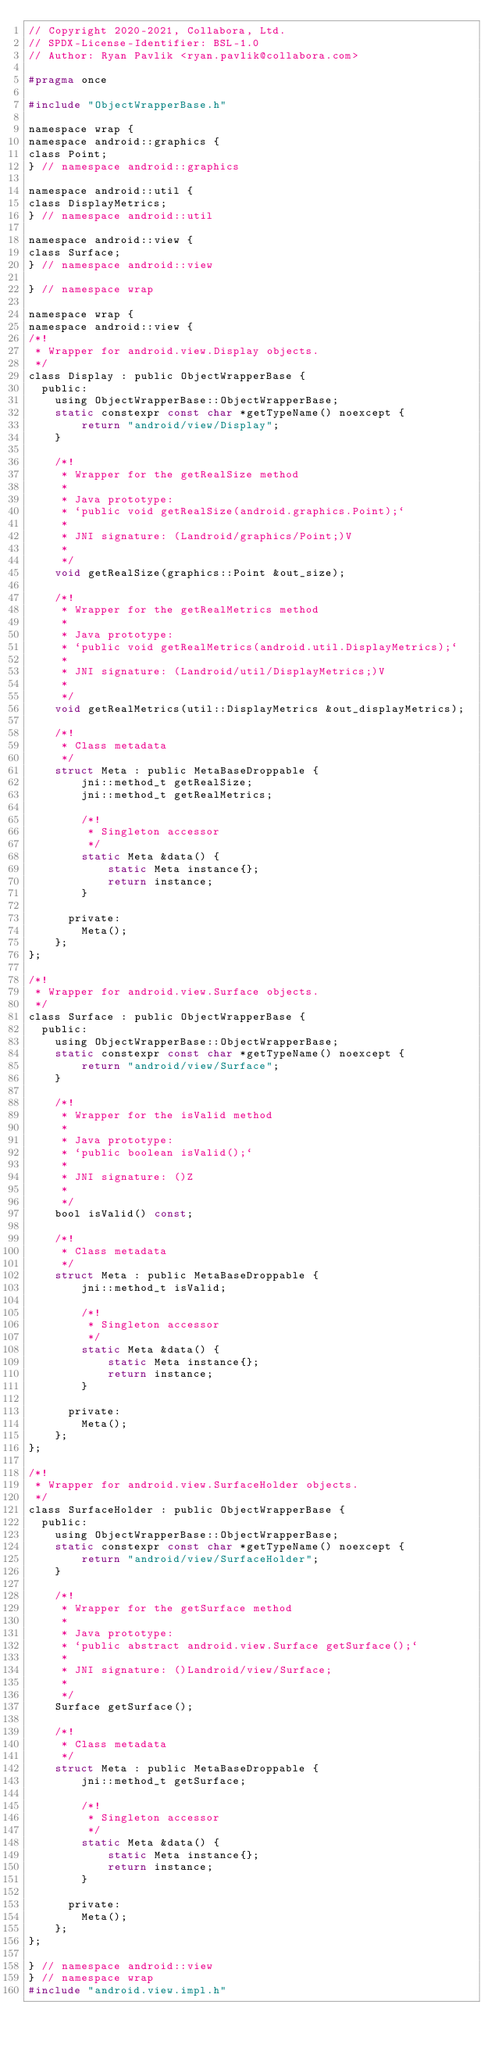Convert code to text. <code><loc_0><loc_0><loc_500><loc_500><_C_>// Copyright 2020-2021, Collabora, Ltd.
// SPDX-License-Identifier: BSL-1.0
// Author: Ryan Pavlik <ryan.pavlik@collabora.com>

#pragma once

#include "ObjectWrapperBase.h"

namespace wrap {
namespace android::graphics {
class Point;
} // namespace android::graphics

namespace android::util {
class DisplayMetrics;
} // namespace android::util

namespace android::view {
class Surface;
} // namespace android::view

} // namespace wrap

namespace wrap {
namespace android::view {
/*!
 * Wrapper for android.view.Display objects.
 */
class Display : public ObjectWrapperBase {
  public:
    using ObjectWrapperBase::ObjectWrapperBase;
    static constexpr const char *getTypeName() noexcept {
        return "android/view/Display";
    }

    /*!
     * Wrapper for the getRealSize method
     *
     * Java prototype:
     * `public void getRealSize(android.graphics.Point);`
     *
     * JNI signature: (Landroid/graphics/Point;)V
     *
     */
    void getRealSize(graphics::Point &out_size);

    /*!
     * Wrapper for the getRealMetrics method
     *
     * Java prototype:
     * `public void getRealMetrics(android.util.DisplayMetrics);`
     *
     * JNI signature: (Landroid/util/DisplayMetrics;)V
     *
     */
    void getRealMetrics(util::DisplayMetrics &out_displayMetrics);

    /*!
     * Class metadata
     */
    struct Meta : public MetaBaseDroppable {
        jni::method_t getRealSize;
        jni::method_t getRealMetrics;

        /*!
         * Singleton accessor
         */
        static Meta &data() {
            static Meta instance{};
            return instance;
        }

      private:
        Meta();
    };
};

/*!
 * Wrapper for android.view.Surface objects.
 */
class Surface : public ObjectWrapperBase {
  public:
    using ObjectWrapperBase::ObjectWrapperBase;
    static constexpr const char *getTypeName() noexcept {
        return "android/view/Surface";
    }

    /*!
     * Wrapper for the isValid method
     *
     * Java prototype:
     * `public boolean isValid();`
     *
     * JNI signature: ()Z
     *
     */
    bool isValid() const;

    /*!
     * Class metadata
     */
    struct Meta : public MetaBaseDroppable {
        jni::method_t isValid;

        /*!
         * Singleton accessor
         */
        static Meta &data() {
            static Meta instance{};
            return instance;
        }

      private:
        Meta();
    };
};

/*!
 * Wrapper for android.view.SurfaceHolder objects.
 */
class SurfaceHolder : public ObjectWrapperBase {
  public:
    using ObjectWrapperBase::ObjectWrapperBase;
    static constexpr const char *getTypeName() noexcept {
        return "android/view/SurfaceHolder";
    }

    /*!
     * Wrapper for the getSurface method
     *
     * Java prototype:
     * `public abstract android.view.Surface getSurface();`
     *
     * JNI signature: ()Landroid/view/Surface;
     *
     */
    Surface getSurface();

    /*!
     * Class metadata
     */
    struct Meta : public MetaBaseDroppable {
        jni::method_t getSurface;

        /*!
         * Singleton accessor
         */
        static Meta &data() {
            static Meta instance{};
            return instance;
        }

      private:
        Meta();
    };
};

} // namespace android::view
} // namespace wrap
#include "android.view.impl.h"
</code> 